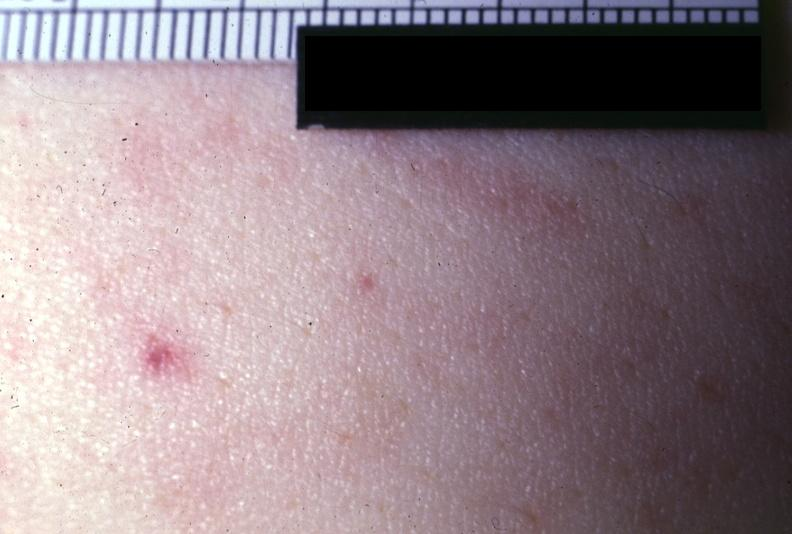s petechiae present?
Answer the question using a single word or phrase. Yes 